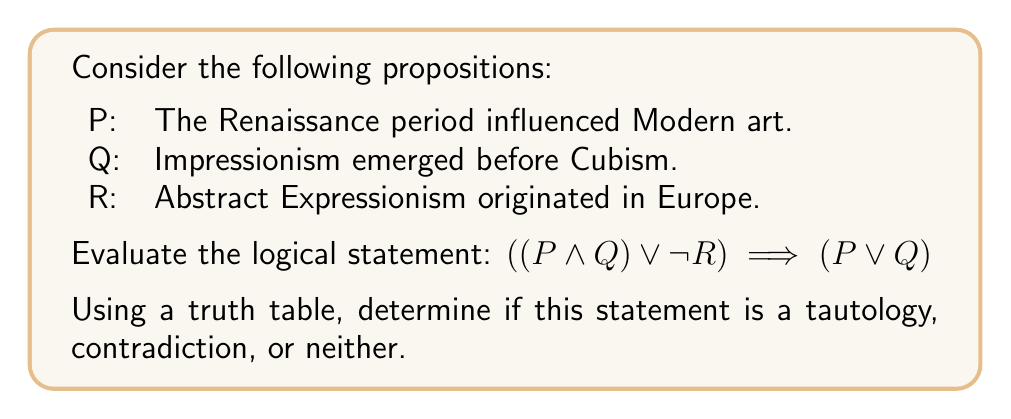Can you answer this question? To evaluate this logical statement, we need to construct a truth table and examine all possible combinations of truth values for P, Q, and R.

1. First, let's break down the statement into its components:
   - Left side of the implication: $((P \land Q) \lor \lnot R)$
   - Right side of the implication: $(P \lor Q)$

2. Construct the truth table:

   | P | Q | R | P ∧ Q | ¬R | (P ∧ Q) ∨ ¬R | P ∨ Q | ((P ∧ Q) ∨ ¬R) → (P ∨ Q) |
   |---|---|---|-------|----|--------------|---------|-----------------------------|
   | T | T | T |   T   | F  |      T       |    T    |              T              |
   | T | T | F |   T   | T  |      T       |    T    |              T              |
   | T | F | T |   F   | F  |      F       |    T    |              T              |
   | T | F | F |   F   | T  |      T       |    T    |              T              |
   | F | T | T |   F   | F  |      F       |    T    |              T              |
   | F | T | F |   F   | T  |      T       |    T    |              T              |
   | F | F | T |   F   | F  |      F       |    F    |              T              |
   | F | F | F |   F   | T  |      T       |    F    |              F              |

3. Analyze the results:
   - The final column represents the truth values of the entire statement.
   - We see that the statement is true for all combinations except when P, Q, and R are all false.

4. Conclusion:
   Since the statement is not true for all possible combinations of truth values, it is not a tautology.
   Since the statement is not false for all possible combinations of truth values, it is not a contradiction.
   Therefore, the statement is neither a tautology nor a contradiction.
Answer: The logical statement $((P \land Q) \lor \lnot R) \implies (P \lor Q)$ is neither a tautology nor a contradiction. 